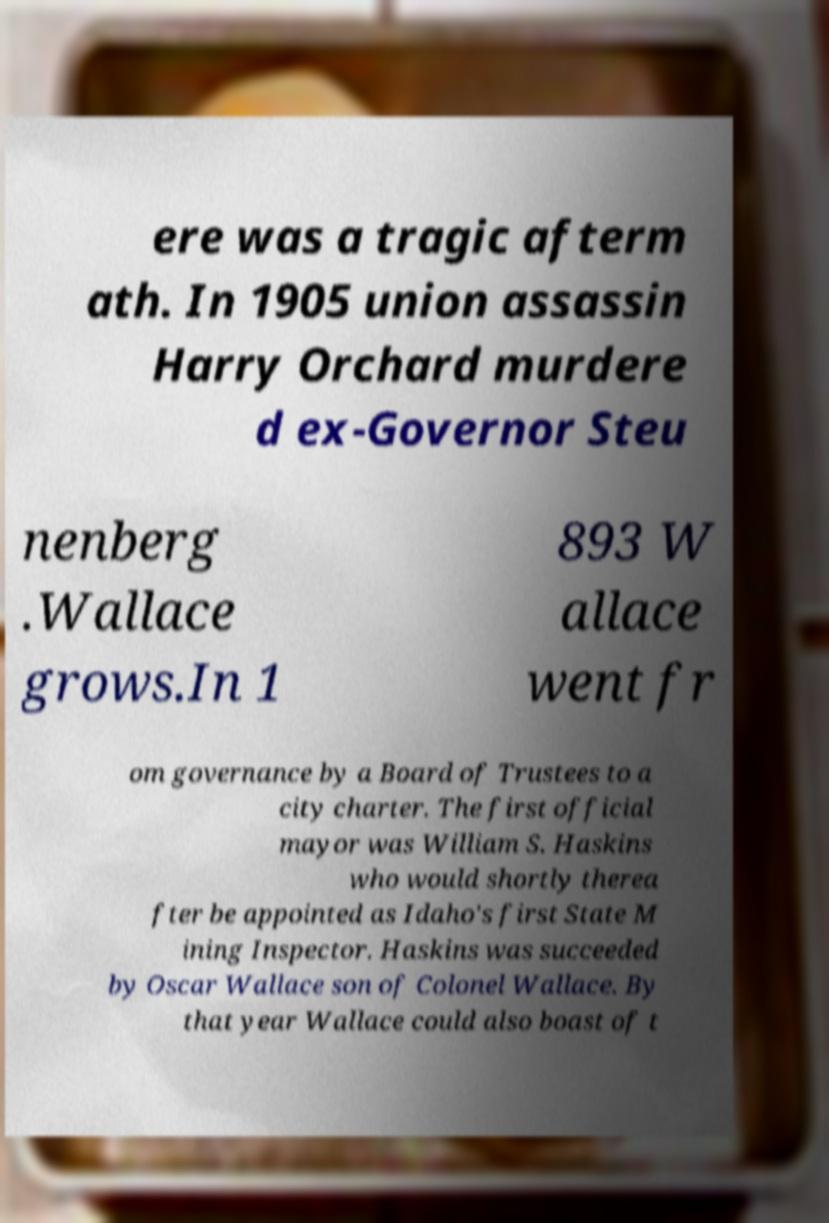Could you assist in decoding the text presented in this image and type it out clearly? ere was a tragic afterm ath. In 1905 union assassin Harry Orchard murdere d ex-Governor Steu nenberg .Wallace grows.In 1 893 W allace went fr om governance by a Board of Trustees to a city charter. The first official mayor was William S. Haskins who would shortly therea fter be appointed as Idaho's first State M ining Inspector. Haskins was succeeded by Oscar Wallace son of Colonel Wallace. By that year Wallace could also boast of t 